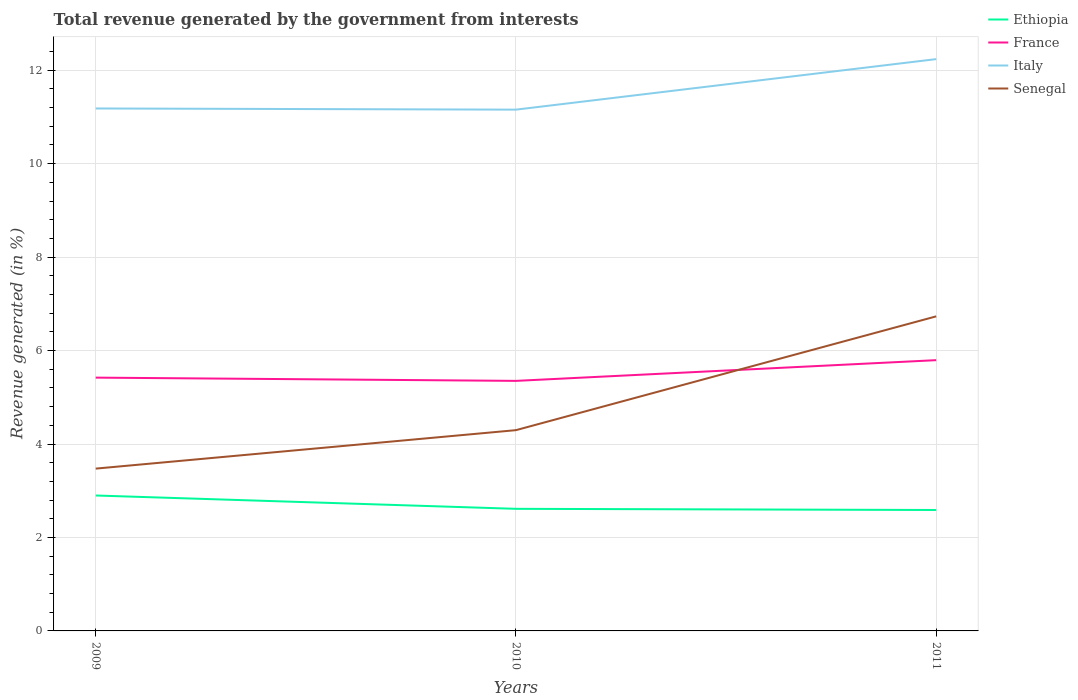How many different coloured lines are there?
Provide a succinct answer. 4. Does the line corresponding to Italy intersect with the line corresponding to Senegal?
Give a very brief answer. No. Across all years, what is the maximum total revenue generated in Italy?
Your response must be concise. 11.16. In which year was the total revenue generated in Italy maximum?
Ensure brevity in your answer.  2010. What is the total total revenue generated in Senegal in the graph?
Your response must be concise. -0.82. What is the difference between the highest and the second highest total revenue generated in Senegal?
Keep it short and to the point. 3.26. What is the difference between the highest and the lowest total revenue generated in Senegal?
Your response must be concise. 1. How many lines are there?
Make the answer very short. 4. How many years are there in the graph?
Your response must be concise. 3. What is the difference between two consecutive major ticks on the Y-axis?
Ensure brevity in your answer.  2. Are the values on the major ticks of Y-axis written in scientific E-notation?
Offer a terse response. No. How many legend labels are there?
Your answer should be compact. 4. How are the legend labels stacked?
Your answer should be very brief. Vertical. What is the title of the graph?
Make the answer very short. Total revenue generated by the government from interests. What is the label or title of the X-axis?
Your answer should be compact. Years. What is the label or title of the Y-axis?
Give a very brief answer. Revenue generated (in %). What is the Revenue generated (in %) of Ethiopia in 2009?
Give a very brief answer. 2.9. What is the Revenue generated (in %) of France in 2009?
Keep it short and to the point. 5.42. What is the Revenue generated (in %) in Italy in 2009?
Provide a short and direct response. 11.18. What is the Revenue generated (in %) in Senegal in 2009?
Give a very brief answer. 3.47. What is the Revenue generated (in %) of Ethiopia in 2010?
Ensure brevity in your answer.  2.61. What is the Revenue generated (in %) in France in 2010?
Provide a succinct answer. 5.35. What is the Revenue generated (in %) of Italy in 2010?
Provide a short and direct response. 11.16. What is the Revenue generated (in %) in Senegal in 2010?
Make the answer very short. 4.3. What is the Revenue generated (in %) in Ethiopia in 2011?
Your response must be concise. 2.59. What is the Revenue generated (in %) in France in 2011?
Your answer should be very brief. 5.79. What is the Revenue generated (in %) in Italy in 2011?
Your response must be concise. 12.24. What is the Revenue generated (in %) of Senegal in 2011?
Your answer should be compact. 6.73. Across all years, what is the maximum Revenue generated (in %) of Ethiopia?
Your answer should be compact. 2.9. Across all years, what is the maximum Revenue generated (in %) of France?
Ensure brevity in your answer.  5.79. Across all years, what is the maximum Revenue generated (in %) in Italy?
Your response must be concise. 12.24. Across all years, what is the maximum Revenue generated (in %) in Senegal?
Give a very brief answer. 6.73. Across all years, what is the minimum Revenue generated (in %) in Ethiopia?
Your response must be concise. 2.59. Across all years, what is the minimum Revenue generated (in %) of France?
Give a very brief answer. 5.35. Across all years, what is the minimum Revenue generated (in %) in Italy?
Offer a very short reply. 11.16. Across all years, what is the minimum Revenue generated (in %) in Senegal?
Ensure brevity in your answer.  3.47. What is the total Revenue generated (in %) in Ethiopia in the graph?
Offer a terse response. 8.1. What is the total Revenue generated (in %) of France in the graph?
Provide a succinct answer. 16.57. What is the total Revenue generated (in %) of Italy in the graph?
Your answer should be very brief. 34.57. What is the total Revenue generated (in %) in Senegal in the graph?
Offer a terse response. 14.5. What is the difference between the Revenue generated (in %) in Ethiopia in 2009 and that in 2010?
Make the answer very short. 0.29. What is the difference between the Revenue generated (in %) in France in 2009 and that in 2010?
Your answer should be very brief. 0.07. What is the difference between the Revenue generated (in %) of Italy in 2009 and that in 2010?
Provide a short and direct response. 0.02. What is the difference between the Revenue generated (in %) of Senegal in 2009 and that in 2010?
Your answer should be compact. -0.82. What is the difference between the Revenue generated (in %) of Ethiopia in 2009 and that in 2011?
Provide a succinct answer. 0.31. What is the difference between the Revenue generated (in %) of France in 2009 and that in 2011?
Provide a succinct answer. -0.37. What is the difference between the Revenue generated (in %) of Italy in 2009 and that in 2011?
Make the answer very short. -1.06. What is the difference between the Revenue generated (in %) of Senegal in 2009 and that in 2011?
Your answer should be very brief. -3.26. What is the difference between the Revenue generated (in %) of Ethiopia in 2010 and that in 2011?
Your response must be concise. 0.03. What is the difference between the Revenue generated (in %) in France in 2010 and that in 2011?
Your answer should be compact. -0.44. What is the difference between the Revenue generated (in %) in Italy in 2010 and that in 2011?
Give a very brief answer. -1.08. What is the difference between the Revenue generated (in %) in Senegal in 2010 and that in 2011?
Offer a terse response. -2.44. What is the difference between the Revenue generated (in %) in Ethiopia in 2009 and the Revenue generated (in %) in France in 2010?
Your answer should be very brief. -2.45. What is the difference between the Revenue generated (in %) in Ethiopia in 2009 and the Revenue generated (in %) in Italy in 2010?
Provide a short and direct response. -8.26. What is the difference between the Revenue generated (in %) of Ethiopia in 2009 and the Revenue generated (in %) of Senegal in 2010?
Offer a very short reply. -1.4. What is the difference between the Revenue generated (in %) of France in 2009 and the Revenue generated (in %) of Italy in 2010?
Ensure brevity in your answer.  -5.73. What is the difference between the Revenue generated (in %) of France in 2009 and the Revenue generated (in %) of Senegal in 2010?
Your answer should be very brief. 1.12. What is the difference between the Revenue generated (in %) of Italy in 2009 and the Revenue generated (in %) of Senegal in 2010?
Give a very brief answer. 6.88. What is the difference between the Revenue generated (in %) of Ethiopia in 2009 and the Revenue generated (in %) of France in 2011?
Keep it short and to the point. -2.9. What is the difference between the Revenue generated (in %) in Ethiopia in 2009 and the Revenue generated (in %) in Italy in 2011?
Your response must be concise. -9.34. What is the difference between the Revenue generated (in %) in Ethiopia in 2009 and the Revenue generated (in %) in Senegal in 2011?
Provide a succinct answer. -3.83. What is the difference between the Revenue generated (in %) in France in 2009 and the Revenue generated (in %) in Italy in 2011?
Give a very brief answer. -6.82. What is the difference between the Revenue generated (in %) of France in 2009 and the Revenue generated (in %) of Senegal in 2011?
Provide a short and direct response. -1.31. What is the difference between the Revenue generated (in %) of Italy in 2009 and the Revenue generated (in %) of Senegal in 2011?
Offer a very short reply. 4.45. What is the difference between the Revenue generated (in %) of Ethiopia in 2010 and the Revenue generated (in %) of France in 2011?
Offer a very short reply. -3.18. What is the difference between the Revenue generated (in %) in Ethiopia in 2010 and the Revenue generated (in %) in Italy in 2011?
Offer a terse response. -9.62. What is the difference between the Revenue generated (in %) of Ethiopia in 2010 and the Revenue generated (in %) of Senegal in 2011?
Your answer should be compact. -4.12. What is the difference between the Revenue generated (in %) of France in 2010 and the Revenue generated (in %) of Italy in 2011?
Your answer should be very brief. -6.89. What is the difference between the Revenue generated (in %) in France in 2010 and the Revenue generated (in %) in Senegal in 2011?
Keep it short and to the point. -1.38. What is the difference between the Revenue generated (in %) in Italy in 2010 and the Revenue generated (in %) in Senegal in 2011?
Offer a very short reply. 4.42. What is the average Revenue generated (in %) of Ethiopia per year?
Provide a succinct answer. 2.7. What is the average Revenue generated (in %) in France per year?
Ensure brevity in your answer.  5.52. What is the average Revenue generated (in %) in Italy per year?
Your response must be concise. 11.52. What is the average Revenue generated (in %) in Senegal per year?
Ensure brevity in your answer.  4.83. In the year 2009, what is the difference between the Revenue generated (in %) in Ethiopia and Revenue generated (in %) in France?
Offer a terse response. -2.52. In the year 2009, what is the difference between the Revenue generated (in %) in Ethiopia and Revenue generated (in %) in Italy?
Provide a short and direct response. -8.28. In the year 2009, what is the difference between the Revenue generated (in %) of Ethiopia and Revenue generated (in %) of Senegal?
Provide a succinct answer. -0.58. In the year 2009, what is the difference between the Revenue generated (in %) in France and Revenue generated (in %) in Italy?
Keep it short and to the point. -5.76. In the year 2009, what is the difference between the Revenue generated (in %) of France and Revenue generated (in %) of Senegal?
Ensure brevity in your answer.  1.95. In the year 2009, what is the difference between the Revenue generated (in %) of Italy and Revenue generated (in %) of Senegal?
Your response must be concise. 7.71. In the year 2010, what is the difference between the Revenue generated (in %) in Ethiopia and Revenue generated (in %) in France?
Offer a very short reply. -2.74. In the year 2010, what is the difference between the Revenue generated (in %) of Ethiopia and Revenue generated (in %) of Italy?
Give a very brief answer. -8.54. In the year 2010, what is the difference between the Revenue generated (in %) of Ethiopia and Revenue generated (in %) of Senegal?
Ensure brevity in your answer.  -1.68. In the year 2010, what is the difference between the Revenue generated (in %) of France and Revenue generated (in %) of Italy?
Make the answer very short. -5.8. In the year 2010, what is the difference between the Revenue generated (in %) in France and Revenue generated (in %) in Senegal?
Your answer should be very brief. 1.05. In the year 2010, what is the difference between the Revenue generated (in %) of Italy and Revenue generated (in %) of Senegal?
Your answer should be compact. 6.86. In the year 2011, what is the difference between the Revenue generated (in %) in Ethiopia and Revenue generated (in %) in France?
Offer a terse response. -3.21. In the year 2011, what is the difference between the Revenue generated (in %) of Ethiopia and Revenue generated (in %) of Italy?
Offer a terse response. -9.65. In the year 2011, what is the difference between the Revenue generated (in %) in Ethiopia and Revenue generated (in %) in Senegal?
Give a very brief answer. -4.14. In the year 2011, what is the difference between the Revenue generated (in %) of France and Revenue generated (in %) of Italy?
Provide a succinct answer. -6.44. In the year 2011, what is the difference between the Revenue generated (in %) in France and Revenue generated (in %) in Senegal?
Your answer should be compact. -0.94. In the year 2011, what is the difference between the Revenue generated (in %) in Italy and Revenue generated (in %) in Senegal?
Ensure brevity in your answer.  5.5. What is the ratio of the Revenue generated (in %) in Ethiopia in 2009 to that in 2010?
Offer a terse response. 1.11. What is the ratio of the Revenue generated (in %) in France in 2009 to that in 2010?
Give a very brief answer. 1.01. What is the ratio of the Revenue generated (in %) in Senegal in 2009 to that in 2010?
Make the answer very short. 0.81. What is the ratio of the Revenue generated (in %) in Ethiopia in 2009 to that in 2011?
Give a very brief answer. 1.12. What is the ratio of the Revenue generated (in %) in France in 2009 to that in 2011?
Offer a very short reply. 0.94. What is the ratio of the Revenue generated (in %) in Italy in 2009 to that in 2011?
Ensure brevity in your answer.  0.91. What is the ratio of the Revenue generated (in %) in Senegal in 2009 to that in 2011?
Offer a terse response. 0.52. What is the ratio of the Revenue generated (in %) of Ethiopia in 2010 to that in 2011?
Ensure brevity in your answer.  1.01. What is the ratio of the Revenue generated (in %) in France in 2010 to that in 2011?
Ensure brevity in your answer.  0.92. What is the ratio of the Revenue generated (in %) of Italy in 2010 to that in 2011?
Provide a short and direct response. 0.91. What is the ratio of the Revenue generated (in %) of Senegal in 2010 to that in 2011?
Make the answer very short. 0.64. What is the difference between the highest and the second highest Revenue generated (in %) in Ethiopia?
Offer a terse response. 0.29. What is the difference between the highest and the second highest Revenue generated (in %) of France?
Your response must be concise. 0.37. What is the difference between the highest and the second highest Revenue generated (in %) of Italy?
Keep it short and to the point. 1.06. What is the difference between the highest and the second highest Revenue generated (in %) in Senegal?
Provide a succinct answer. 2.44. What is the difference between the highest and the lowest Revenue generated (in %) of Ethiopia?
Provide a succinct answer. 0.31. What is the difference between the highest and the lowest Revenue generated (in %) of France?
Your response must be concise. 0.44. What is the difference between the highest and the lowest Revenue generated (in %) in Italy?
Make the answer very short. 1.08. What is the difference between the highest and the lowest Revenue generated (in %) of Senegal?
Provide a short and direct response. 3.26. 